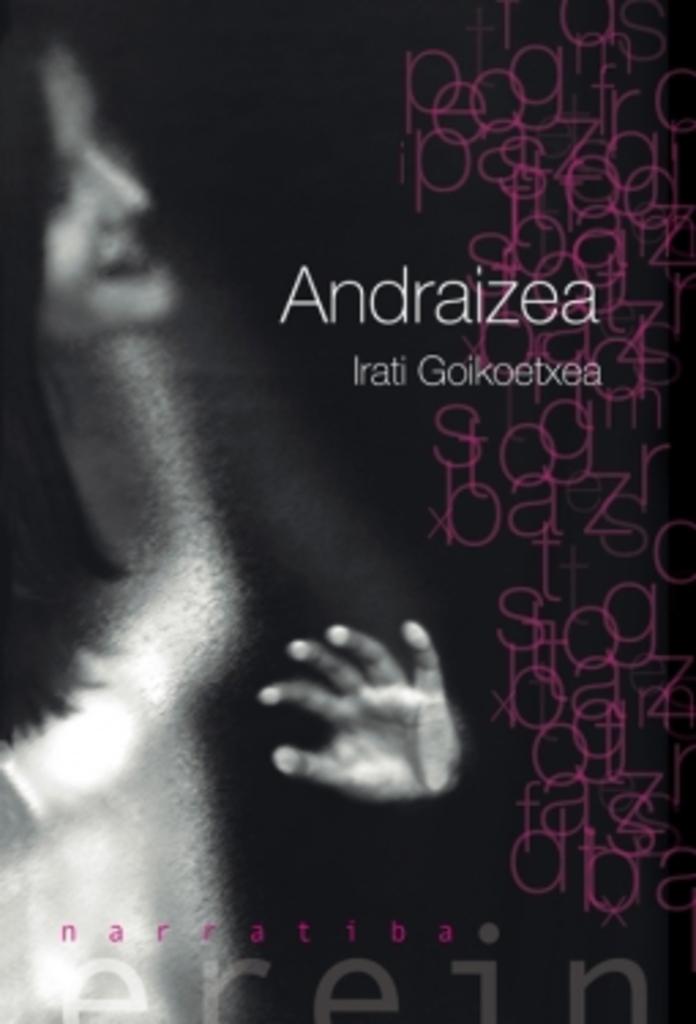Who wrote this book?
Keep it short and to the point. Irati goikoetxea. 